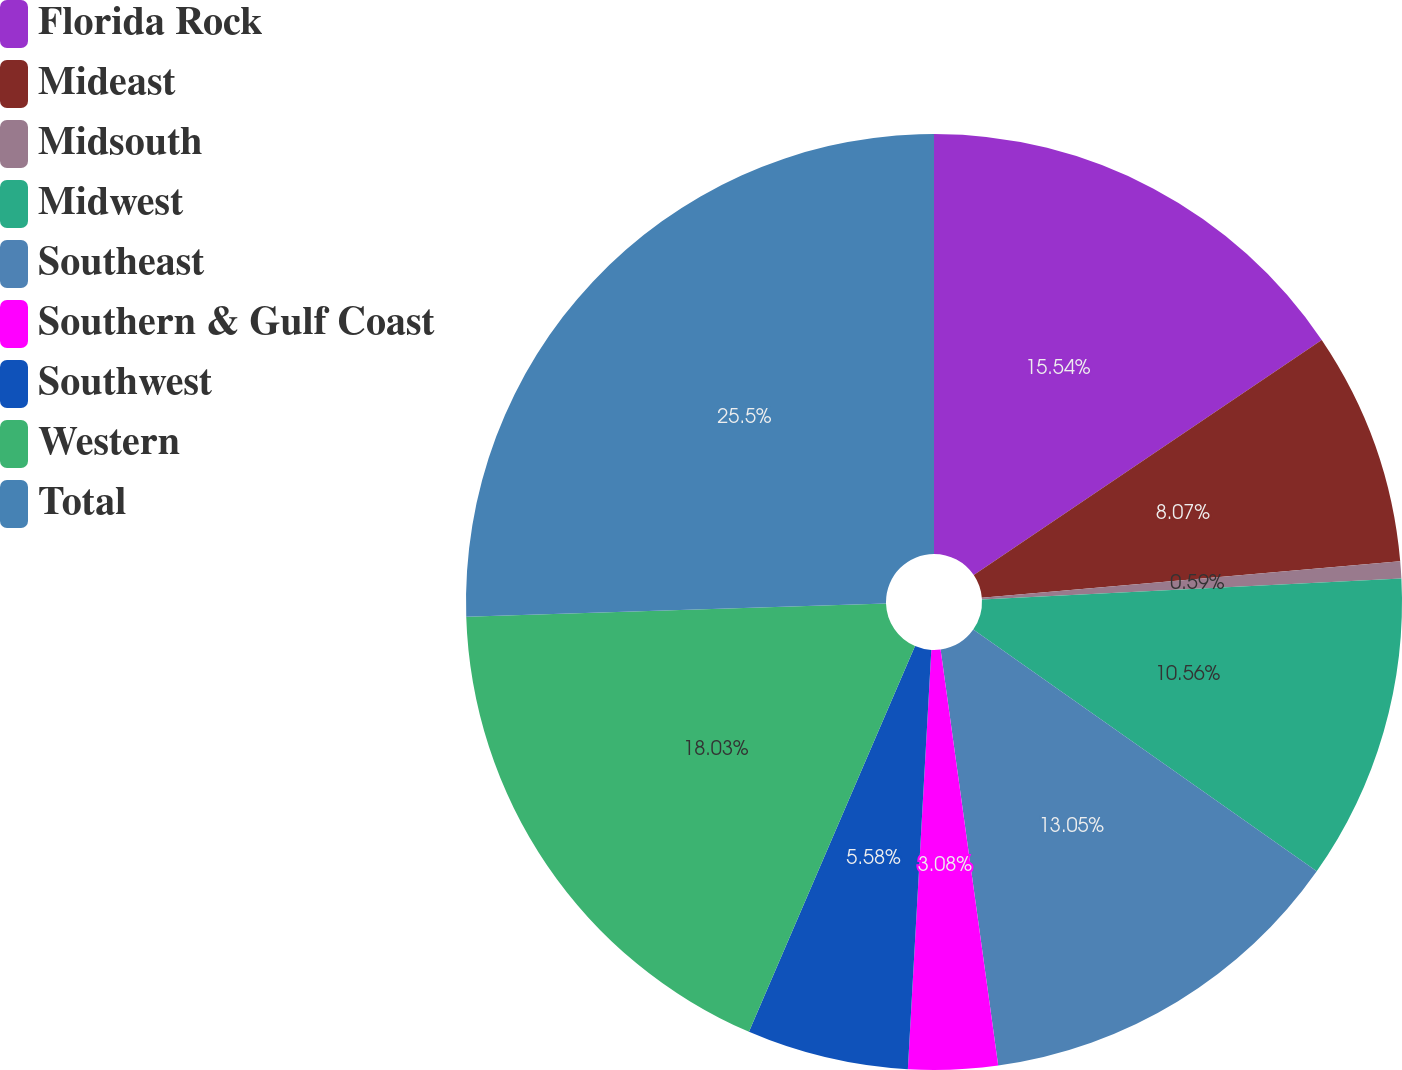Convert chart to OTSL. <chart><loc_0><loc_0><loc_500><loc_500><pie_chart><fcel>Florida Rock<fcel>Mideast<fcel>Midsouth<fcel>Midwest<fcel>Southeast<fcel>Southern & Gulf Coast<fcel>Southwest<fcel>Western<fcel>Total<nl><fcel>15.54%<fcel>8.07%<fcel>0.59%<fcel>10.56%<fcel>13.05%<fcel>3.08%<fcel>5.58%<fcel>18.03%<fcel>25.5%<nl></chart> 